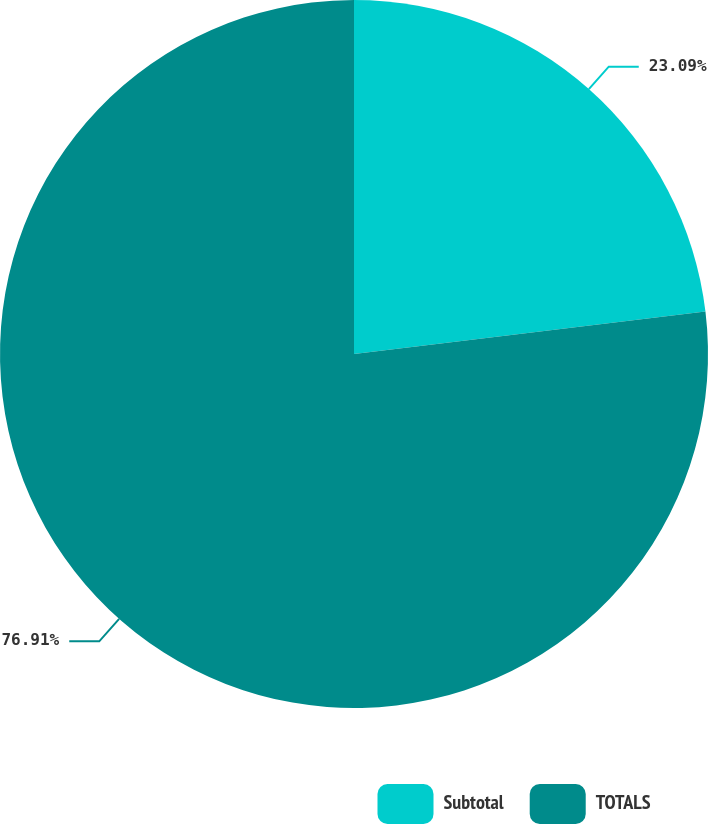Convert chart to OTSL. <chart><loc_0><loc_0><loc_500><loc_500><pie_chart><fcel>Subtotal<fcel>TOTALS<nl><fcel>23.09%<fcel>76.91%<nl></chart> 